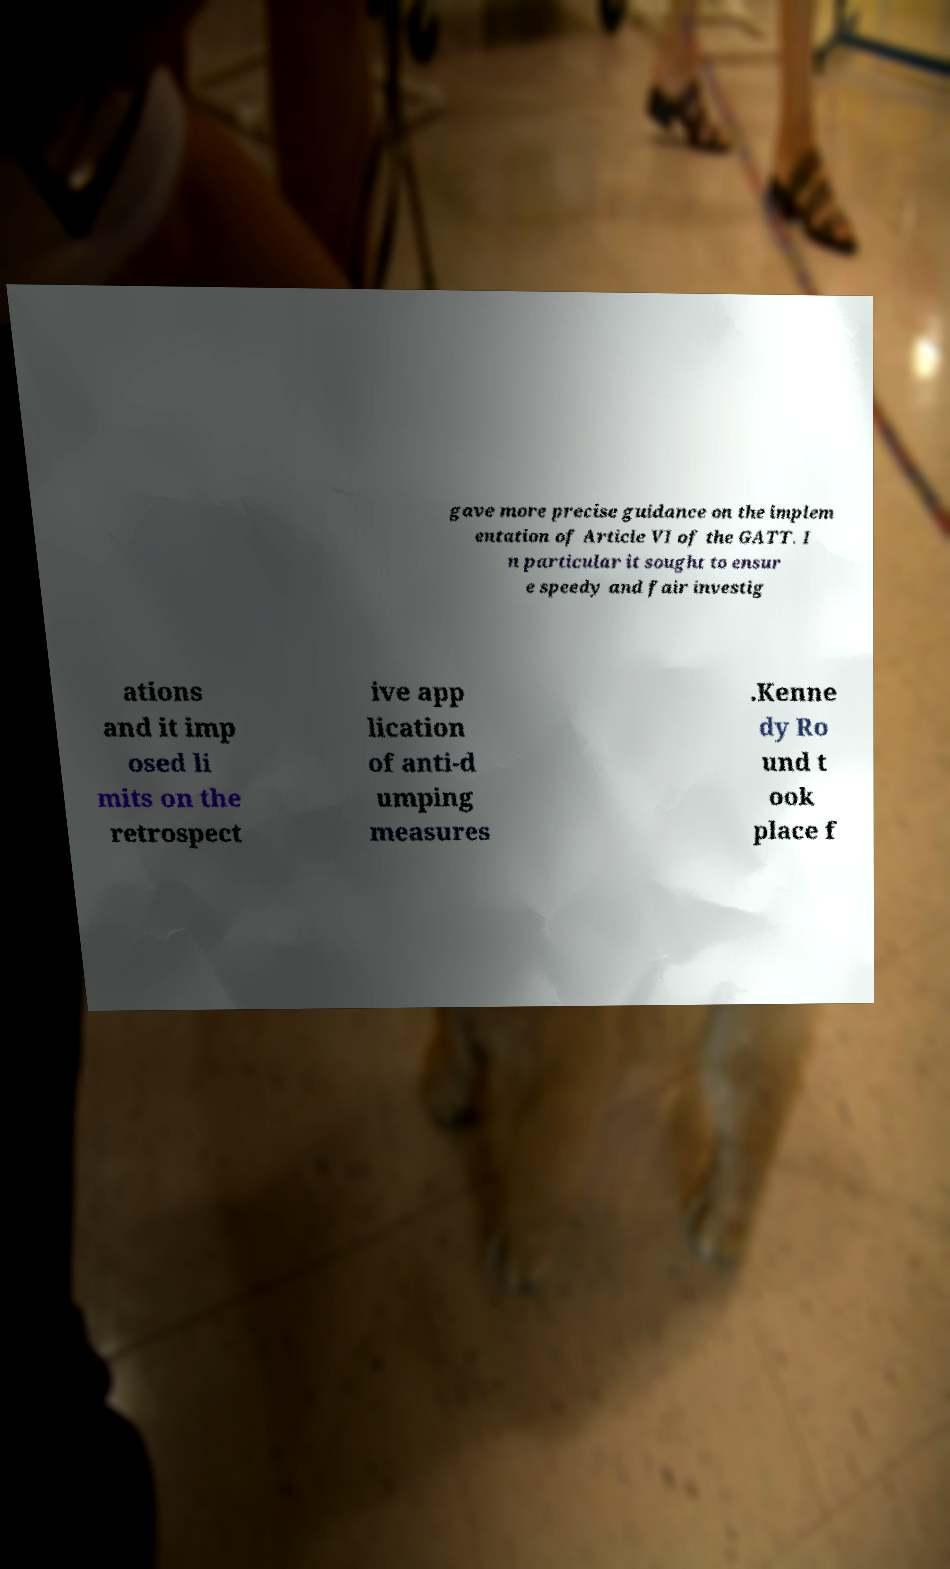Could you extract and type out the text from this image? gave more precise guidance on the implem entation of Article VI of the GATT. I n particular it sought to ensur e speedy and fair investig ations and it imp osed li mits on the retrospect ive app lication of anti-d umping measures .Kenne dy Ro und t ook place f 